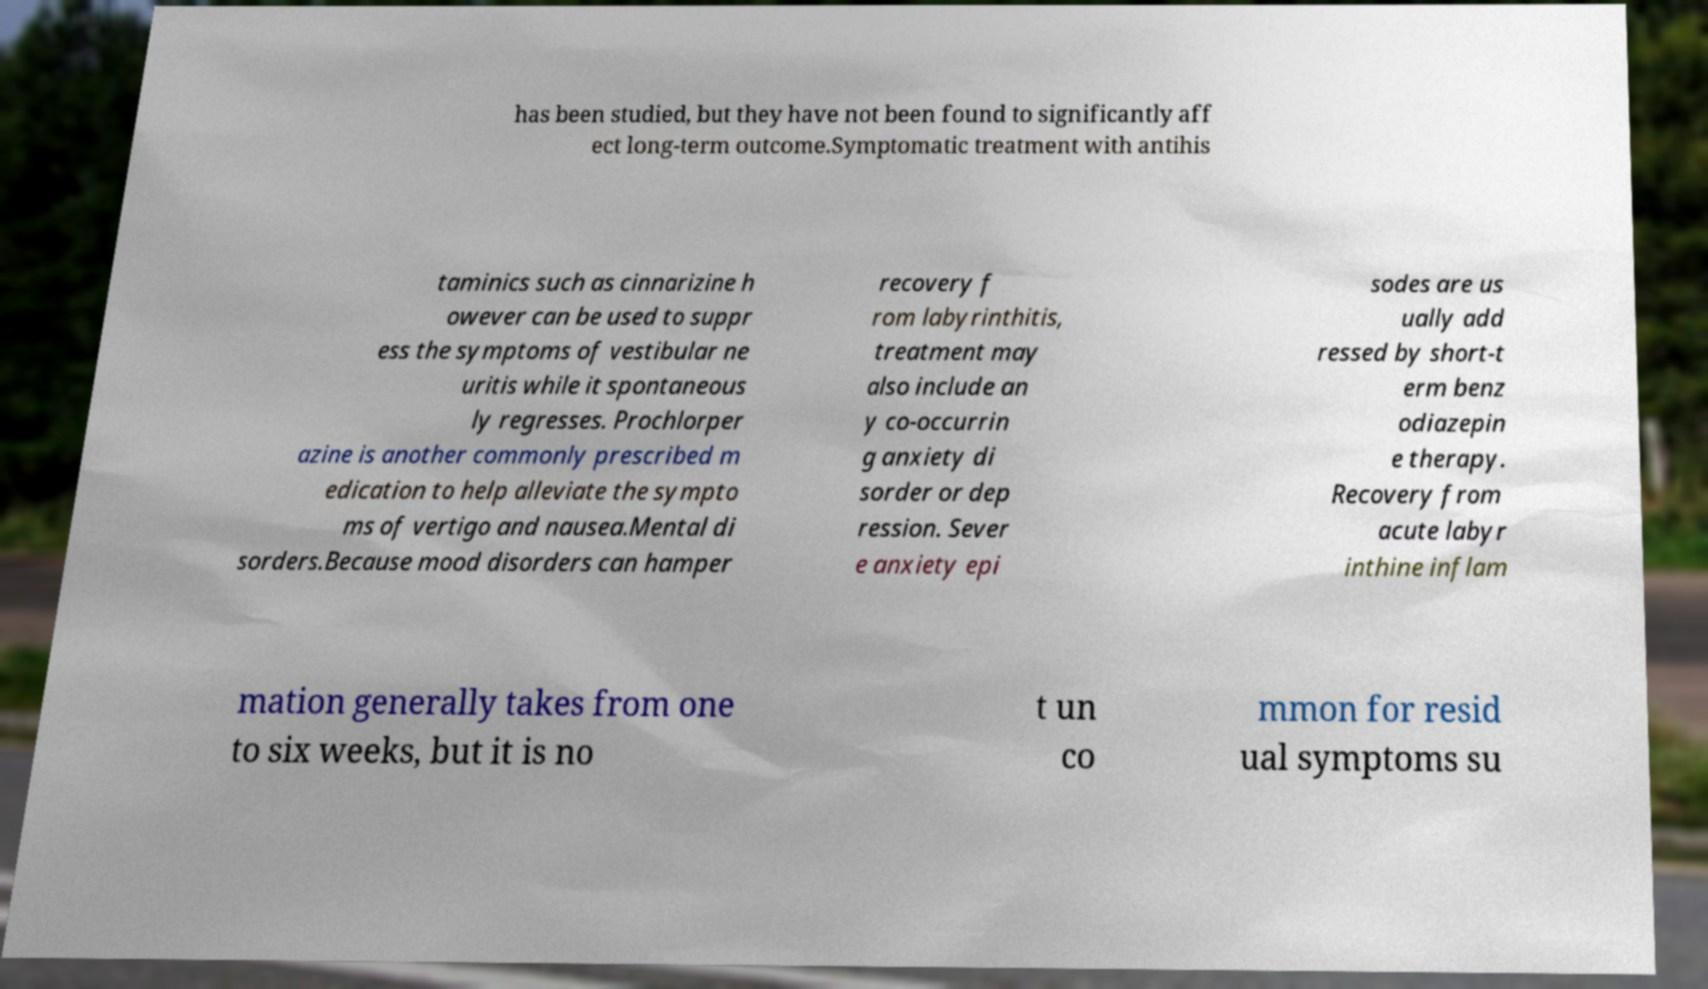There's text embedded in this image that I need extracted. Can you transcribe it verbatim? has been studied, but they have not been found to significantly aff ect long-term outcome.Symptomatic treatment with antihis taminics such as cinnarizine h owever can be used to suppr ess the symptoms of vestibular ne uritis while it spontaneous ly regresses. Prochlorper azine is another commonly prescribed m edication to help alleviate the sympto ms of vertigo and nausea.Mental di sorders.Because mood disorders can hamper recovery f rom labyrinthitis, treatment may also include an y co-occurrin g anxiety di sorder or dep ression. Sever e anxiety epi sodes are us ually add ressed by short-t erm benz odiazepin e therapy. Recovery from acute labyr inthine inflam mation generally takes from one to six weeks, but it is no t un co mmon for resid ual symptoms su 